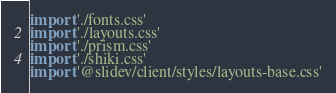<code> <loc_0><loc_0><loc_500><loc_500><_TypeScript_>import './fonts.css'
import './layouts.css'
import './prism.css'
import './shiki.css'
import '@slidev/client/styles/layouts-base.css'
</code> 